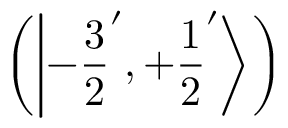<formula> <loc_0><loc_0><loc_500><loc_500>\left ( \left | - { \frac { 3 } { 2 } } ^ { \prime } , + { \frac { 1 } { 2 } } ^ { \prime } \right \rangle \right )</formula> 